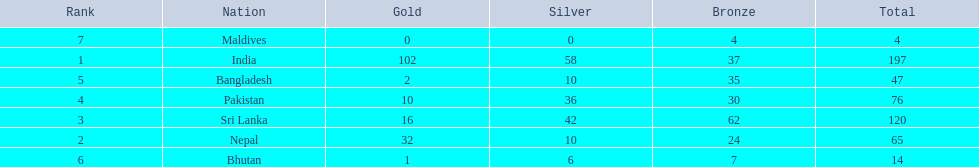What are the totals of medals one in each country? 197, 65, 120, 76, 47, 14, 4. Which of these totals are less than 10? 4. Who won this number of medals? Maldives. 